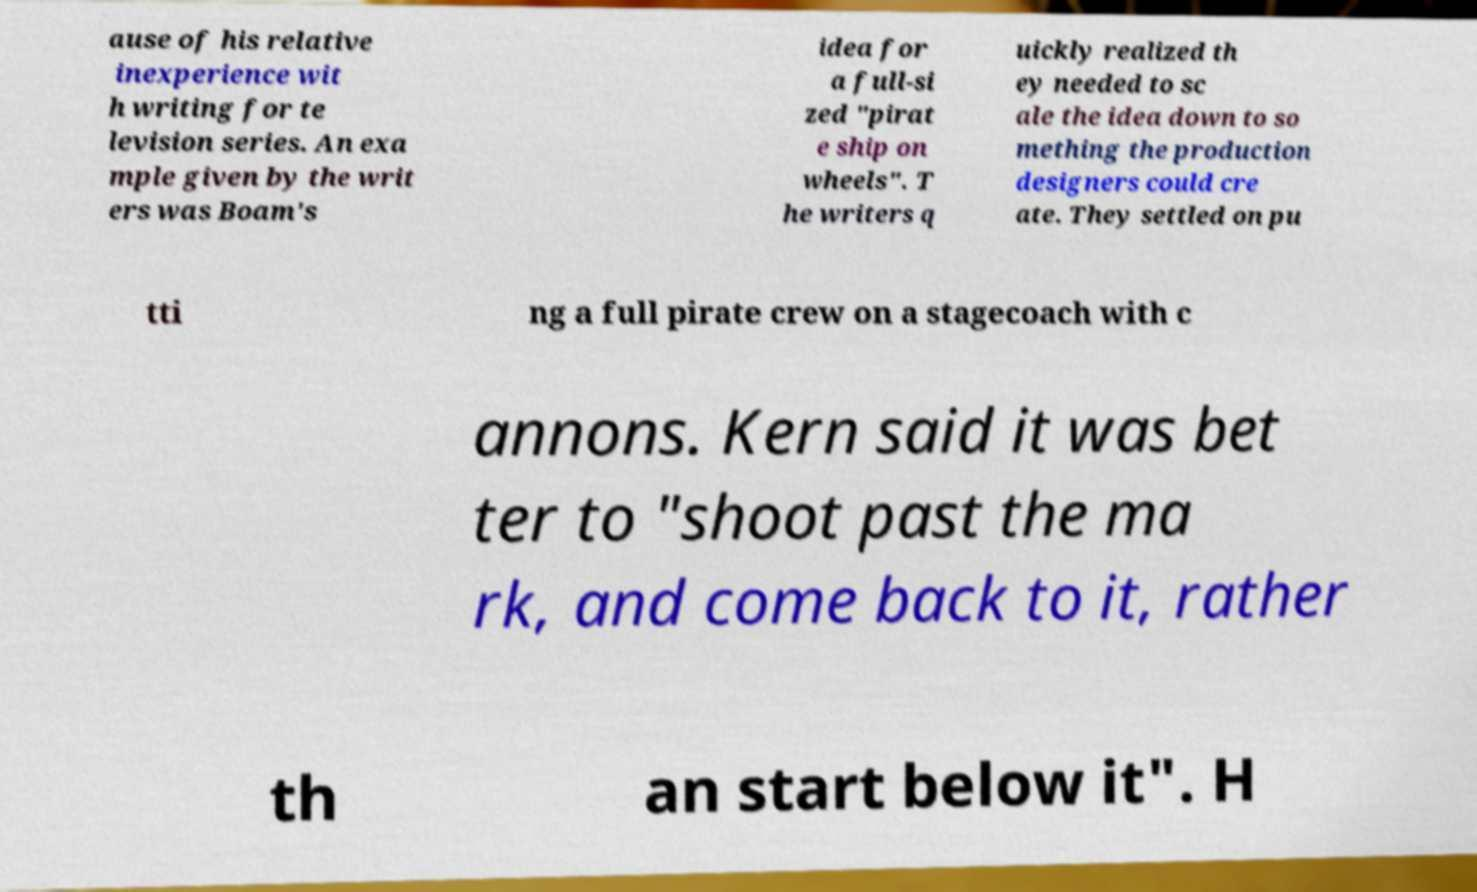I need the written content from this picture converted into text. Can you do that? ause of his relative inexperience wit h writing for te levision series. An exa mple given by the writ ers was Boam's idea for a full-si zed "pirat e ship on wheels". T he writers q uickly realized th ey needed to sc ale the idea down to so mething the production designers could cre ate. They settled on pu tti ng a full pirate crew on a stagecoach with c annons. Kern said it was bet ter to "shoot past the ma rk, and come back to it, rather th an start below it". H 